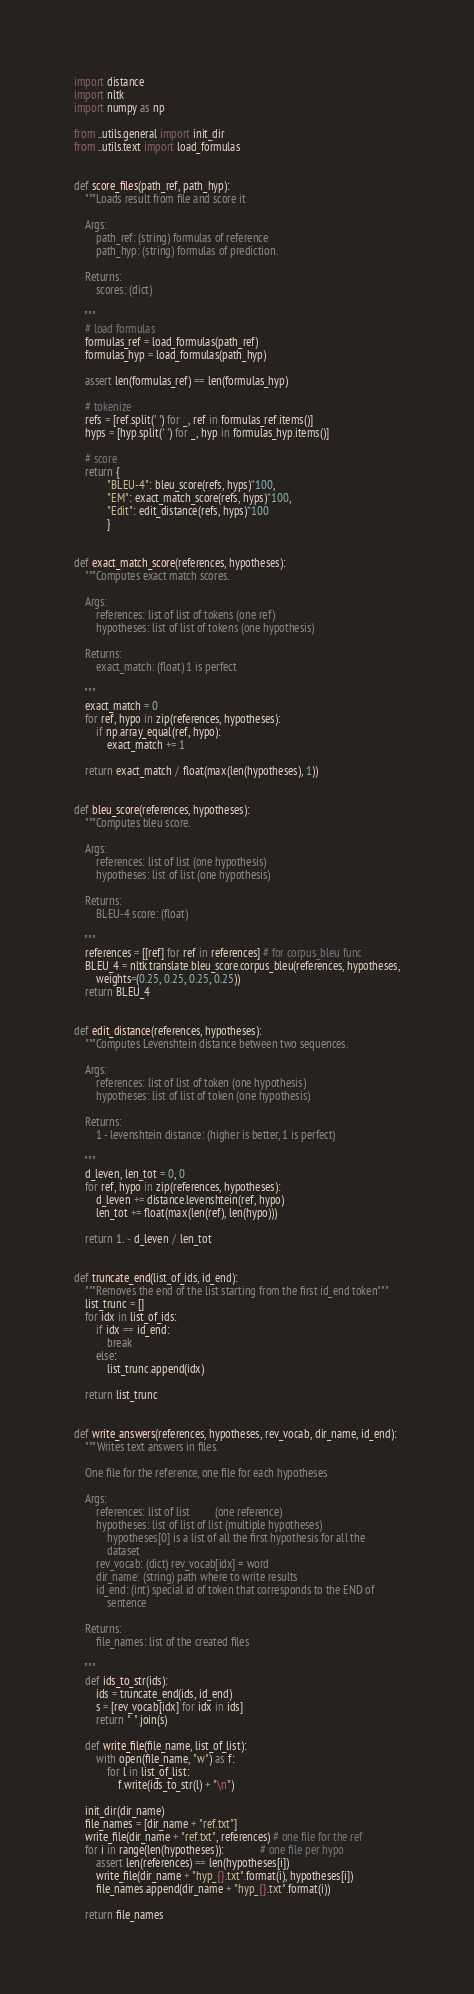<code> <loc_0><loc_0><loc_500><loc_500><_Python_>import distance
import nltk
import numpy as np

from ..utils.general import init_dir
from ..utils.text import load_formulas


def score_files(path_ref, path_hyp):
    """Loads result from file and score it

    Args:
        path_ref: (string) formulas of reference
        path_hyp: (string) formulas of prediction.

    Returns:
        scores: (dict)

    """
    # load formulas
    formulas_ref = load_formulas(path_ref)
    formulas_hyp = load_formulas(path_hyp)

    assert len(formulas_ref) == len(formulas_hyp)

    # tokenize
    refs = [ref.split(' ') for _, ref in formulas_ref.items()]
    hyps = [hyp.split(' ') for _, hyp in formulas_hyp.items()]

    # score
    return {
            "BLEU-4": bleu_score(refs, hyps)*100,
            "EM": exact_match_score(refs, hyps)*100,
            "Edit": edit_distance(refs, hyps)*100
            }


def exact_match_score(references, hypotheses):
    """Computes exact match scores.

    Args:
        references: list of list of tokens (one ref)
        hypotheses: list of list of tokens (one hypothesis)

    Returns:
        exact_match: (float) 1 is perfect

    """
    exact_match = 0
    for ref, hypo in zip(references, hypotheses):
        if np.array_equal(ref, hypo):
            exact_match += 1

    return exact_match / float(max(len(hypotheses), 1))


def bleu_score(references, hypotheses):
    """Computes bleu score.

    Args:
        references: list of list (one hypothesis)
        hypotheses: list of list (one hypothesis)

    Returns:
        BLEU-4 score: (float)

    """
    references = [[ref] for ref in references] # for corpus_bleu func
    BLEU_4 = nltk.translate.bleu_score.corpus_bleu(references, hypotheses,
        weights=(0.25, 0.25, 0.25, 0.25))
    return BLEU_4


def edit_distance(references, hypotheses):
    """Computes Levenshtein distance between two sequences.

    Args:
        references: list of list of token (one hypothesis)
        hypotheses: list of list of token (one hypothesis)

    Returns:
        1 - levenshtein distance: (higher is better, 1 is perfect)

    """
    d_leven, len_tot = 0, 0
    for ref, hypo in zip(references, hypotheses):
        d_leven += distance.levenshtein(ref, hypo)
        len_tot += float(max(len(ref), len(hypo)))

    return 1. - d_leven / len_tot


def truncate_end(list_of_ids, id_end):
    """Removes the end of the list starting from the first id_end token"""
    list_trunc = []
    for idx in list_of_ids:
        if idx == id_end:
            break
        else:
            list_trunc.append(idx)

    return list_trunc


def write_answers(references, hypotheses, rev_vocab, dir_name, id_end):
    """Writes text answers in files.

    One file for the reference, one file for each hypotheses

    Args:
        references: list of list         (one reference)
        hypotheses: list of list of list (multiple hypotheses)
            hypotheses[0] is a list of all the first hypothesis for all the
            dataset
        rev_vocab: (dict) rev_vocab[idx] = word
        dir_name: (string) path where to write results
        id_end: (int) special id of token that corresponds to the END of
            sentence

    Returns:
        file_names: list of the created files

    """
    def ids_to_str(ids):
        ids = truncate_end(ids, id_end)
        s = [rev_vocab[idx] for idx in ids]
        return " ".join(s)

    def write_file(file_name, list_of_list):
        with open(file_name, "w") as f:
            for l in list_of_list:
                f.write(ids_to_str(l) + "\n")

    init_dir(dir_name)
    file_names = [dir_name + "ref.txt"]
    write_file(dir_name + "ref.txt", references) # one file for the ref
    for i in range(len(hypotheses)):             # one file per hypo
        assert len(references) == len(hypotheses[i])
        write_file(dir_name + "hyp_{}.txt".format(i), hypotheses[i])
        file_names.append(dir_name + "hyp_{}.txt".format(i))

    return file_names

</code> 